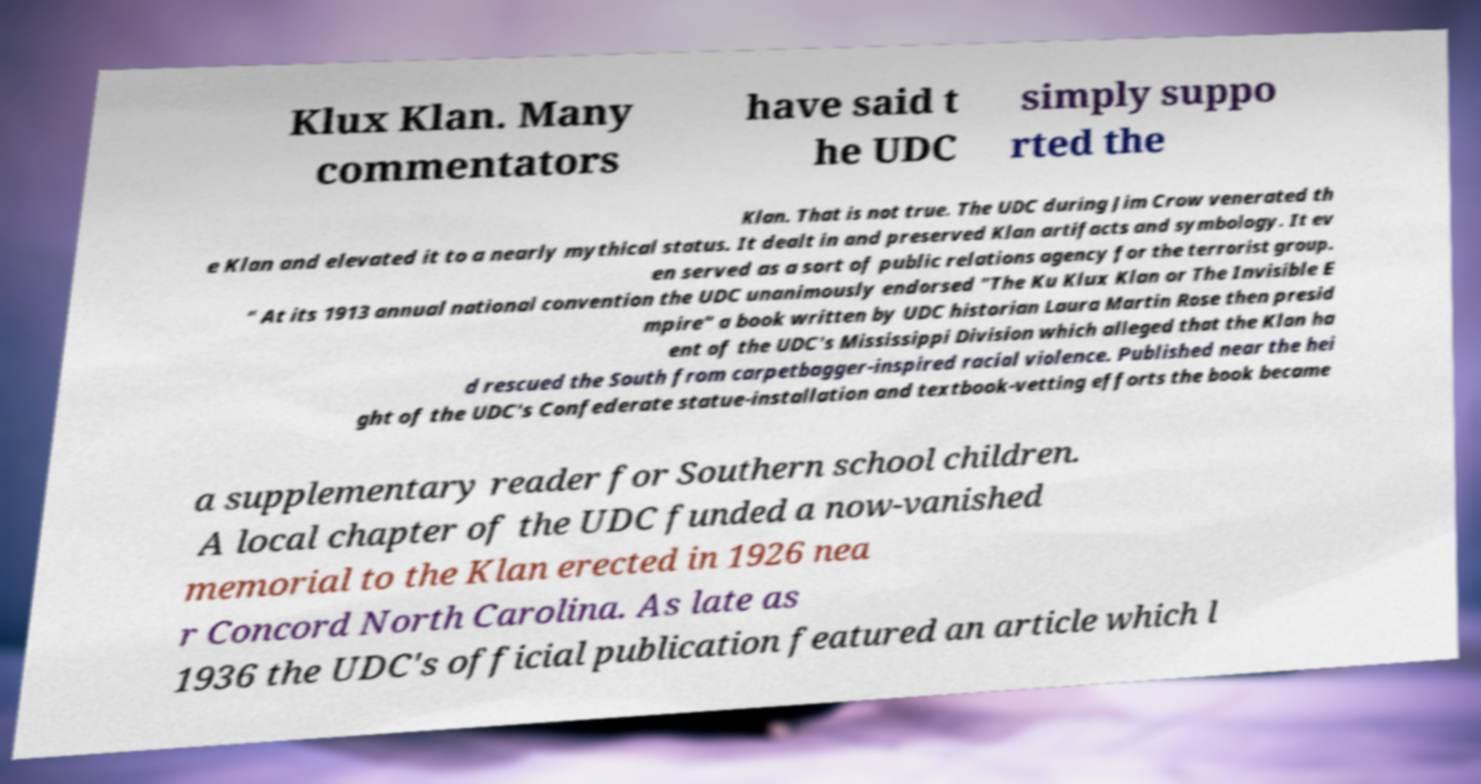What messages or text are displayed in this image? I need them in a readable, typed format. Klux Klan. Many commentators have said t he UDC simply suppo rted the Klan. That is not true. The UDC during Jim Crow venerated th e Klan and elevated it to a nearly mythical status. It dealt in and preserved Klan artifacts and symbology. It ev en served as a sort of public relations agency for the terrorist group. " At its 1913 annual national convention the UDC unanimously endorsed "The Ku Klux Klan or The Invisible E mpire" a book written by UDC historian Laura Martin Rose then presid ent of the UDC's Mississippi Division which alleged that the Klan ha d rescued the South from carpetbagger-inspired racial violence. Published near the hei ght of the UDC's Confederate statue-installation and textbook-vetting efforts the book became a supplementary reader for Southern school children. A local chapter of the UDC funded a now-vanished memorial to the Klan erected in 1926 nea r Concord North Carolina. As late as 1936 the UDC's official publication featured an article which l 